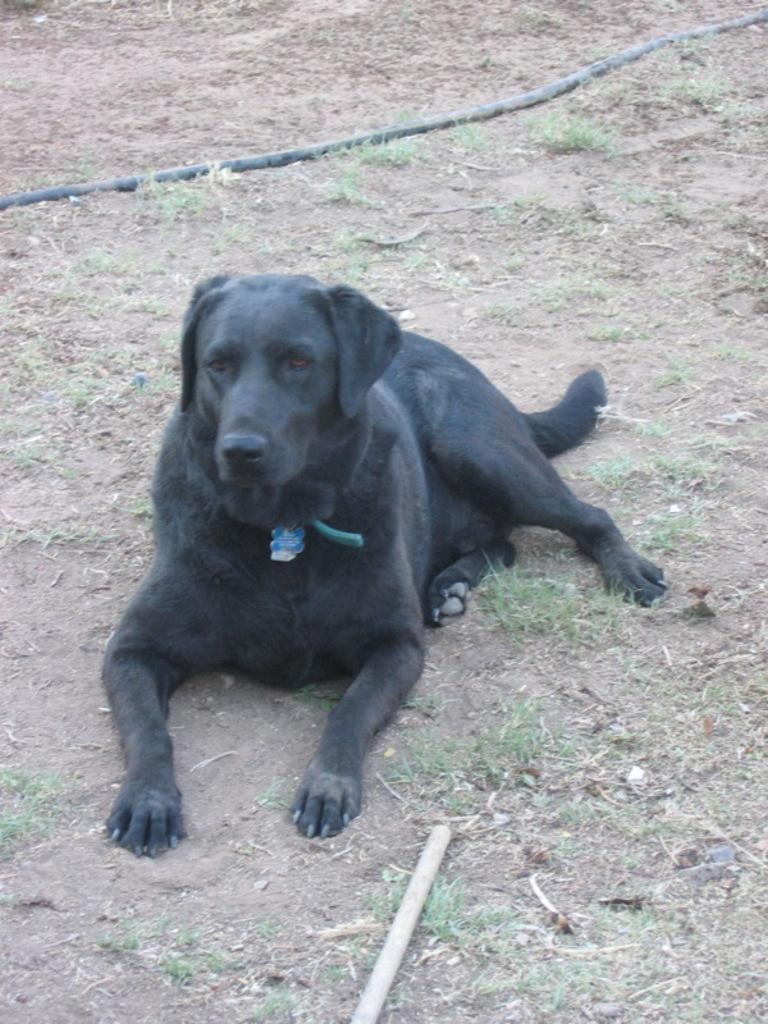What type of animal is in the image? There is a black color dog in the image. What object can be seen at the bottom of the image? There is a stick at the bottom of the image. What is the color and type of object at the top of the image? There is a pipe in black color at the top of the image. What type of amusement can be seen in the image? There is no amusement present in the image; it features a dog, a stick, and a pipe. How many circles are visible in the image? There are no circles visible in the image. 